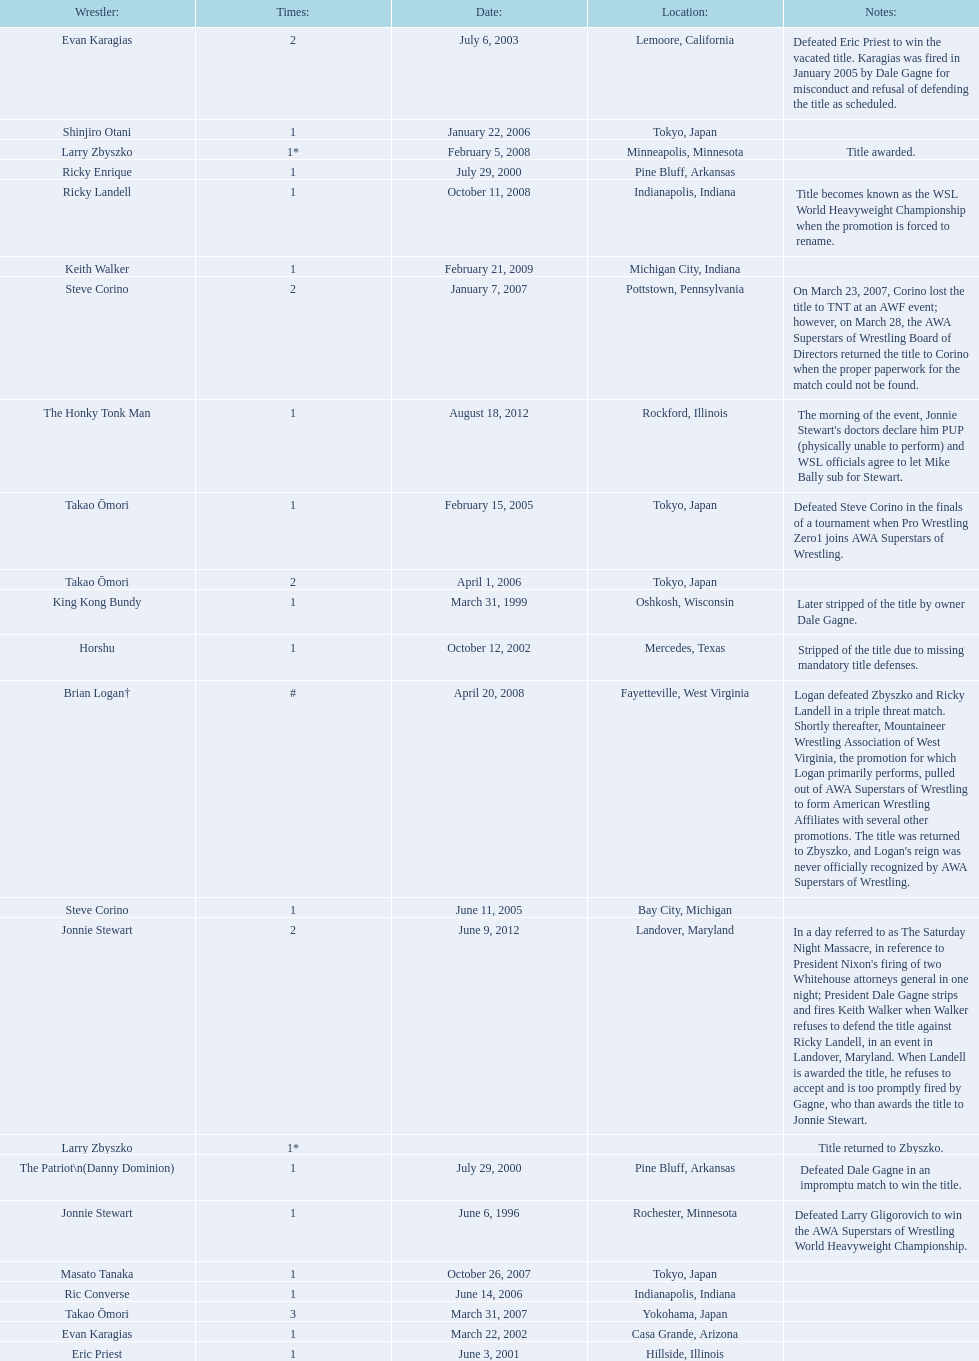Who are all of the wrestlers? Jonnie Stewart, King Kong Bundy, The Patriot\n(Danny Dominion), Ricky Enrique, Eric Priest, Evan Karagias, Horshu, Evan Karagias, Takao Ōmori, Steve Corino, Shinjiro Otani, Takao Ōmori, Ric Converse, Steve Corino, Takao Ōmori, Masato Tanaka, Larry Zbyszko, Brian Logan†, Larry Zbyszko, Ricky Landell, Keith Walker, Jonnie Stewart, The Honky Tonk Man. Where are they from? Rochester, Minnesota, Oshkosh, Wisconsin, Pine Bluff, Arkansas, Pine Bluff, Arkansas, Hillside, Illinois, Casa Grande, Arizona, Mercedes, Texas, Lemoore, California, Tokyo, Japan, Bay City, Michigan, Tokyo, Japan, Tokyo, Japan, Indianapolis, Indiana, Pottstown, Pennsylvania, Yokohama, Japan, Tokyo, Japan, Minneapolis, Minnesota, Fayetteville, West Virginia, , Indianapolis, Indiana, Michigan City, Indiana, Landover, Maryland, Rockford, Illinois. And which of them is from texas? Horshu. 